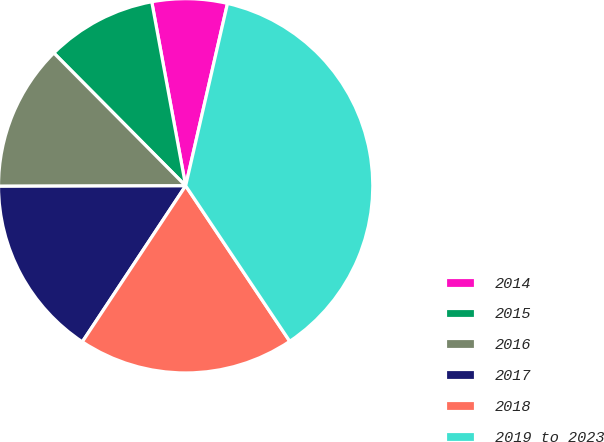Convert chart. <chart><loc_0><loc_0><loc_500><loc_500><pie_chart><fcel>2014<fcel>2015<fcel>2016<fcel>2017<fcel>2018<fcel>2019 to 2023<nl><fcel>6.49%<fcel>9.54%<fcel>12.6%<fcel>15.65%<fcel>18.7%<fcel>37.02%<nl></chart> 